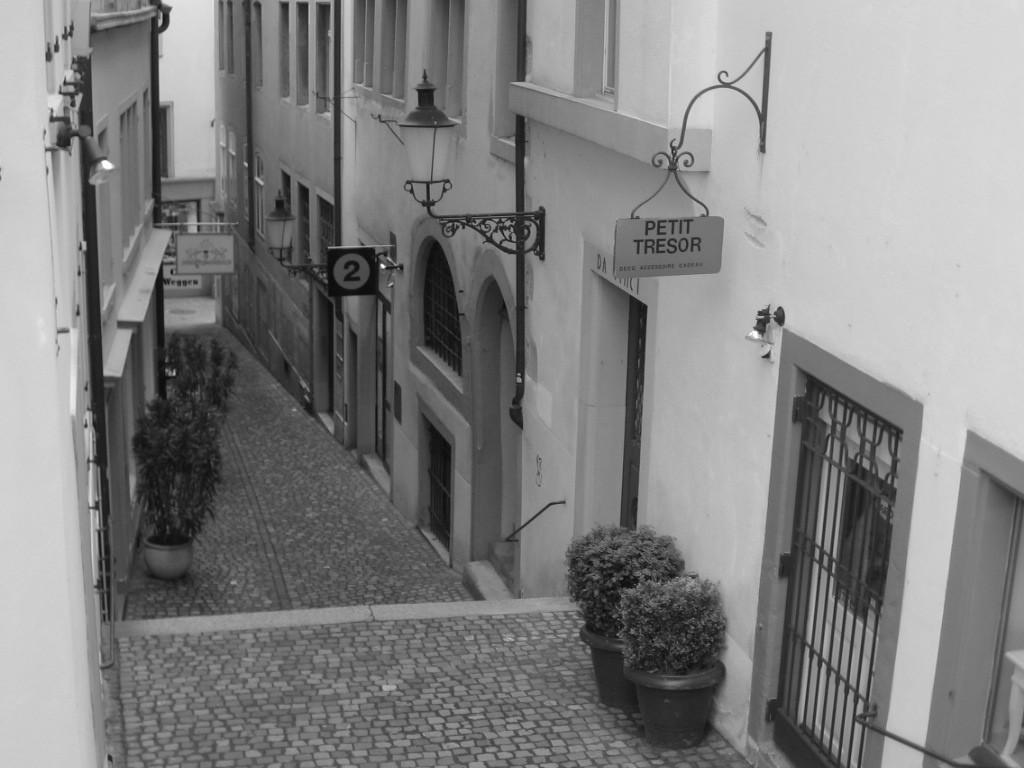What is located in the center of the image? There are plants in the center of the image. What can be seen in the background of the image? There are buildings in the background of the image. What objects are visible in the image that might be used for displaying information or advertisements? There are boards visible in the image. What can be seen in the image that might provide illumination? There are lights visible in the image. What type of bead is being used to control the train in the image? There is no train or bead present in the image. What observation can be made about the plants in the image? The provided facts do not include any information about the plants' condition or appearance, so no specific observation can be made. 